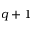<formula> <loc_0><loc_0><loc_500><loc_500>q + 1</formula> 